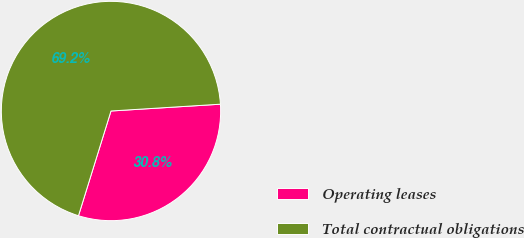Convert chart. <chart><loc_0><loc_0><loc_500><loc_500><pie_chart><fcel>Operating leases<fcel>Total contractual obligations<nl><fcel>30.78%<fcel>69.22%<nl></chart> 